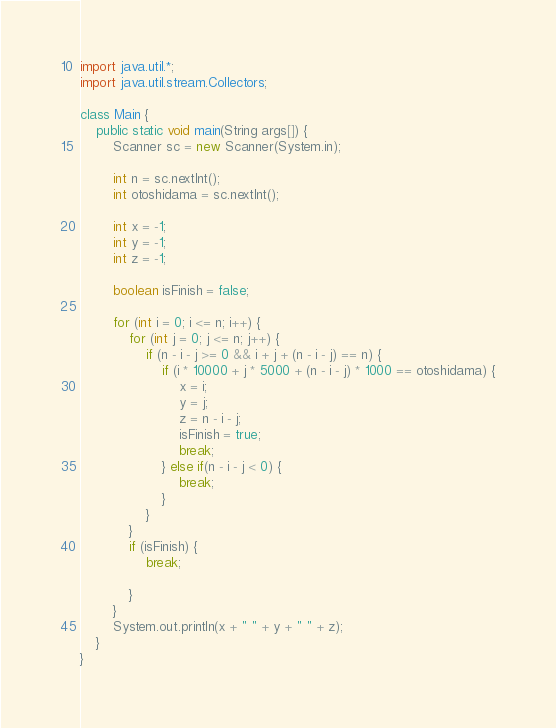<code> <loc_0><loc_0><loc_500><loc_500><_Java_>import java.util.*;
import java.util.stream.Collectors;

class Main {
    public static void main(String args[]) {
        Scanner sc = new Scanner(System.in);
      
        int n = sc.nextInt();
        int otoshidama = sc.nextInt();

        int x = -1;
        int y = -1;
        int z = -1;

        boolean isFinish = false;

        for (int i = 0; i <= n; i++) {
            for (int j = 0; j <= n; j++) {
                if (n - i - j >= 0 && i + j + (n - i - j) == n) {
                    if (i * 10000 + j * 5000 + (n - i - j) * 1000 == otoshidama) {
                        x = i;
                        y = j;
                        z = n - i - j;
                        isFinish = true;
                        break;
                    } else if(n - i - j < 0) {
                        break;
                    }
                }
            }
            if (isFinish) {
                break;

            }
        }
        System.out.println(x + " " + y + " " + z);
    }
}</code> 